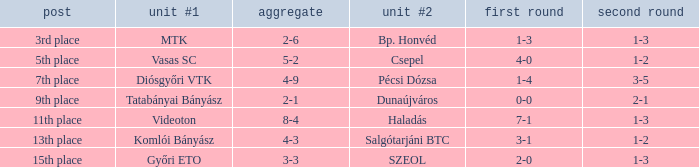What is the 1st leg of bp. honvéd team #2? 1-3. 